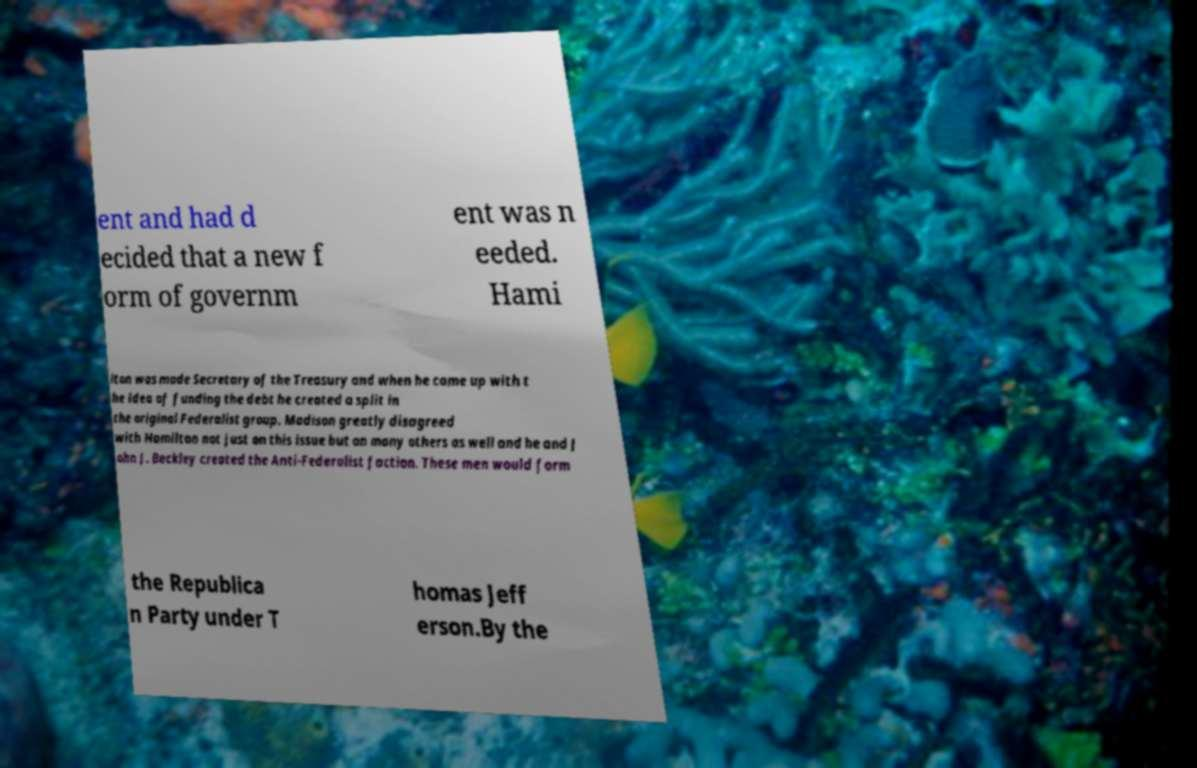Could you extract and type out the text from this image? ent and had d ecided that a new f orm of governm ent was n eeded. Hami lton was made Secretary of the Treasury and when he came up with t he idea of funding the debt he created a split in the original Federalist group. Madison greatly disagreed with Hamilton not just on this issue but on many others as well and he and J ohn J. Beckley created the Anti-Federalist faction. These men would form the Republica n Party under T homas Jeff erson.By the 